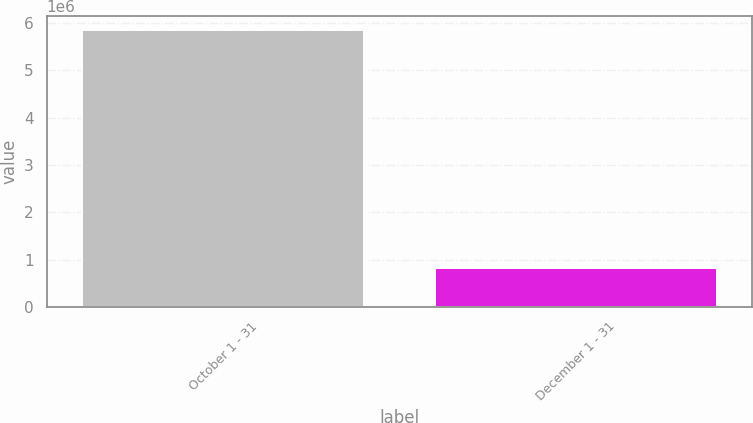Convert chart to OTSL. <chart><loc_0><loc_0><loc_500><loc_500><bar_chart><fcel>October 1 - 31<fcel>December 1 - 31<nl><fcel>5.84952e+06<fcel>826639<nl></chart> 